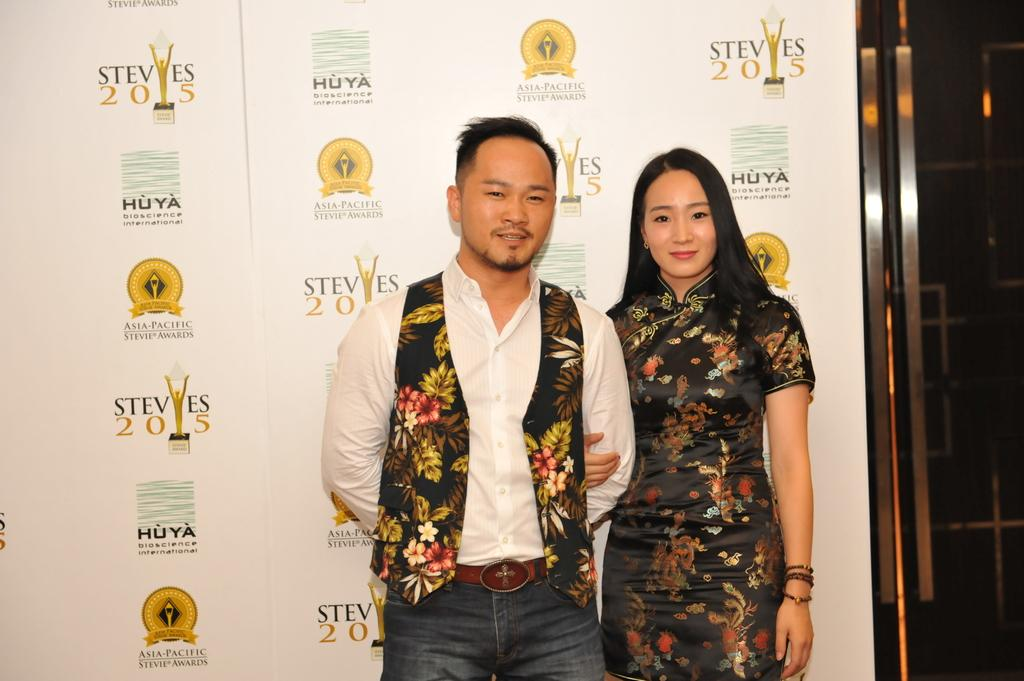Who is present in the image? There is a man and a lady in the image. What are the man and lady doing in the image? The man and lady are standing. What can be seen in the background of the image? There is a board with text and logos, as well as stands in the background. How much straw is being used by the man and lady in the image? There is no straw present in the image. What type of society is depicted in the image? The image does not depict a society; it features a man and a lady standing with a background containing a board and stands. 